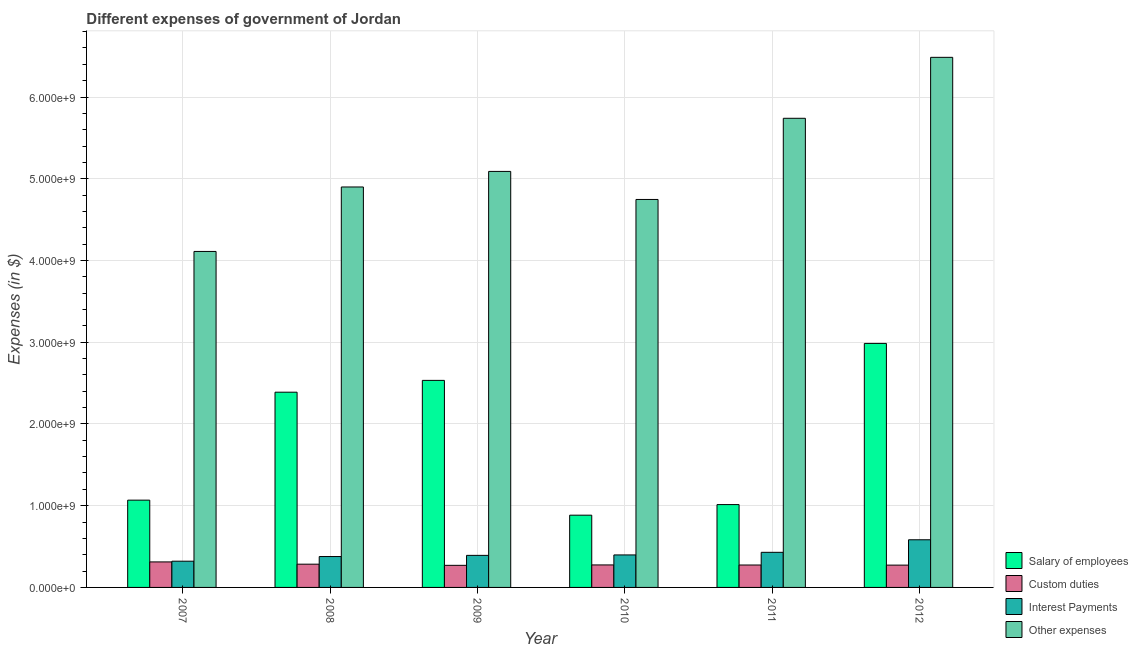How many groups of bars are there?
Ensure brevity in your answer.  6. Are the number of bars per tick equal to the number of legend labels?
Give a very brief answer. Yes. Are the number of bars on each tick of the X-axis equal?
Make the answer very short. Yes. How many bars are there on the 6th tick from the right?
Provide a succinct answer. 4. In how many cases, is the number of bars for a given year not equal to the number of legend labels?
Your answer should be compact. 0. What is the amount spent on custom duties in 2007?
Provide a succinct answer. 3.12e+08. Across all years, what is the maximum amount spent on interest payments?
Make the answer very short. 5.83e+08. Across all years, what is the minimum amount spent on custom duties?
Offer a terse response. 2.70e+08. What is the total amount spent on other expenses in the graph?
Provide a short and direct response. 3.11e+1. What is the difference between the amount spent on interest payments in 2011 and that in 2012?
Your response must be concise. -1.54e+08. What is the difference between the amount spent on other expenses in 2009 and the amount spent on custom duties in 2007?
Offer a very short reply. 9.79e+08. What is the average amount spent on other expenses per year?
Give a very brief answer. 5.18e+09. In the year 2012, what is the difference between the amount spent on interest payments and amount spent on salary of employees?
Offer a terse response. 0. What is the ratio of the amount spent on salary of employees in 2008 to that in 2012?
Your response must be concise. 0.8. Is the amount spent on custom duties in 2007 less than that in 2011?
Your answer should be very brief. No. What is the difference between the highest and the second highest amount spent on salary of employees?
Offer a terse response. 4.52e+08. What is the difference between the highest and the lowest amount spent on interest payments?
Your answer should be compact. 2.62e+08. Is the sum of the amount spent on interest payments in 2009 and 2012 greater than the maximum amount spent on custom duties across all years?
Offer a terse response. Yes. Is it the case that in every year, the sum of the amount spent on custom duties and amount spent on other expenses is greater than the sum of amount spent on interest payments and amount spent on salary of employees?
Ensure brevity in your answer.  No. What does the 1st bar from the left in 2010 represents?
Give a very brief answer. Salary of employees. What does the 1st bar from the right in 2010 represents?
Your response must be concise. Other expenses. Are all the bars in the graph horizontal?
Provide a short and direct response. No. How many years are there in the graph?
Make the answer very short. 6. What is the difference between two consecutive major ticks on the Y-axis?
Your answer should be compact. 1.00e+09. What is the title of the graph?
Offer a very short reply. Different expenses of government of Jordan. What is the label or title of the Y-axis?
Keep it short and to the point. Expenses (in $). What is the Expenses (in $) in Salary of employees in 2007?
Offer a very short reply. 1.07e+09. What is the Expenses (in $) of Custom duties in 2007?
Make the answer very short. 3.12e+08. What is the Expenses (in $) in Interest Payments in 2007?
Provide a succinct answer. 3.21e+08. What is the Expenses (in $) of Other expenses in 2007?
Your answer should be very brief. 4.11e+09. What is the Expenses (in $) of Salary of employees in 2008?
Your answer should be compact. 2.39e+09. What is the Expenses (in $) in Custom duties in 2008?
Keep it short and to the point. 2.84e+08. What is the Expenses (in $) of Interest Payments in 2008?
Make the answer very short. 3.78e+08. What is the Expenses (in $) in Other expenses in 2008?
Give a very brief answer. 4.90e+09. What is the Expenses (in $) in Salary of employees in 2009?
Your response must be concise. 2.53e+09. What is the Expenses (in $) of Custom duties in 2009?
Make the answer very short. 2.70e+08. What is the Expenses (in $) in Interest Payments in 2009?
Your answer should be compact. 3.92e+08. What is the Expenses (in $) of Other expenses in 2009?
Keep it short and to the point. 5.09e+09. What is the Expenses (in $) of Salary of employees in 2010?
Your answer should be compact. 8.84e+08. What is the Expenses (in $) in Custom duties in 2010?
Keep it short and to the point. 2.75e+08. What is the Expenses (in $) of Interest Payments in 2010?
Make the answer very short. 3.98e+08. What is the Expenses (in $) of Other expenses in 2010?
Make the answer very short. 4.75e+09. What is the Expenses (in $) of Salary of employees in 2011?
Make the answer very short. 1.01e+09. What is the Expenses (in $) of Custom duties in 2011?
Your response must be concise. 2.74e+08. What is the Expenses (in $) in Interest Payments in 2011?
Keep it short and to the point. 4.30e+08. What is the Expenses (in $) in Other expenses in 2011?
Provide a short and direct response. 5.74e+09. What is the Expenses (in $) in Salary of employees in 2012?
Provide a succinct answer. 2.99e+09. What is the Expenses (in $) of Custom duties in 2012?
Your answer should be compact. 2.73e+08. What is the Expenses (in $) in Interest Payments in 2012?
Your response must be concise. 5.83e+08. What is the Expenses (in $) of Other expenses in 2012?
Provide a succinct answer. 6.49e+09. Across all years, what is the maximum Expenses (in $) in Salary of employees?
Your answer should be compact. 2.99e+09. Across all years, what is the maximum Expenses (in $) in Custom duties?
Provide a short and direct response. 3.12e+08. Across all years, what is the maximum Expenses (in $) in Interest Payments?
Your answer should be compact. 5.83e+08. Across all years, what is the maximum Expenses (in $) of Other expenses?
Ensure brevity in your answer.  6.49e+09. Across all years, what is the minimum Expenses (in $) of Salary of employees?
Your answer should be compact. 8.84e+08. Across all years, what is the minimum Expenses (in $) of Custom duties?
Offer a very short reply. 2.70e+08. Across all years, what is the minimum Expenses (in $) of Interest Payments?
Offer a very short reply. 3.21e+08. Across all years, what is the minimum Expenses (in $) of Other expenses?
Provide a short and direct response. 4.11e+09. What is the total Expenses (in $) in Salary of employees in the graph?
Provide a short and direct response. 1.09e+1. What is the total Expenses (in $) of Custom duties in the graph?
Provide a short and direct response. 1.69e+09. What is the total Expenses (in $) of Interest Payments in the graph?
Provide a succinct answer. 2.50e+09. What is the total Expenses (in $) in Other expenses in the graph?
Your answer should be compact. 3.11e+1. What is the difference between the Expenses (in $) of Salary of employees in 2007 and that in 2008?
Provide a short and direct response. -1.32e+09. What is the difference between the Expenses (in $) in Custom duties in 2007 and that in 2008?
Offer a terse response. 2.77e+07. What is the difference between the Expenses (in $) of Interest Payments in 2007 and that in 2008?
Give a very brief answer. -5.69e+07. What is the difference between the Expenses (in $) in Other expenses in 2007 and that in 2008?
Offer a terse response. -7.89e+08. What is the difference between the Expenses (in $) of Salary of employees in 2007 and that in 2009?
Your answer should be compact. -1.47e+09. What is the difference between the Expenses (in $) of Custom duties in 2007 and that in 2009?
Make the answer very short. 4.18e+07. What is the difference between the Expenses (in $) of Interest Payments in 2007 and that in 2009?
Your answer should be compact. -7.13e+07. What is the difference between the Expenses (in $) of Other expenses in 2007 and that in 2009?
Make the answer very short. -9.79e+08. What is the difference between the Expenses (in $) of Salary of employees in 2007 and that in 2010?
Your response must be concise. 1.84e+08. What is the difference between the Expenses (in $) in Custom duties in 2007 and that in 2010?
Your answer should be very brief. 3.69e+07. What is the difference between the Expenses (in $) of Interest Payments in 2007 and that in 2010?
Your response must be concise. -7.66e+07. What is the difference between the Expenses (in $) of Other expenses in 2007 and that in 2010?
Your answer should be compact. -6.36e+08. What is the difference between the Expenses (in $) in Salary of employees in 2007 and that in 2011?
Provide a succinct answer. 5.42e+07. What is the difference between the Expenses (in $) of Custom duties in 2007 and that in 2011?
Your response must be concise. 3.79e+07. What is the difference between the Expenses (in $) in Interest Payments in 2007 and that in 2011?
Provide a short and direct response. -1.09e+08. What is the difference between the Expenses (in $) of Other expenses in 2007 and that in 2011?
Your answer should be very brief. -1.63e+09. What is the difference between the Expenses (in $) in Salary of employees in 2007 and that in 2012?
Offer a terse response. -1.92e+09. What is the difference between the Expenses (in $) in Custom duties in 2007 and that in 2012?
Your response must be concise. 3.91e+07. What is the difference between the Expenses (in $) in Interest Payments in 2007 and that in 2012?
Make the answer very short. -2.62e+08. What is the difference between the Expenses (in $) of Other expenses in 2007 and that in 2012?
Provide a succinct answer. -2.37e+09. What is the difference between the Expenses (in $) in Salary of employees in 2008 and that in 2009?
Give a very brief answer. -1.44e+08. What is the difference between the Expenses (in $) of Custom duties in 2008 and that in 2009?
Ensure brevity in your answer.  1.41e+07. What is the difference between the Expenses (in $) in Interest Payments in 2008 and that in 2009?
Provide a short and direct response. -1.44e+07. What is the difference between the Expenses (in $) in Other expenses in 2008 and that in 2009?
Your answer should be compact. -1.90e+08. What is the difference between the Expenses (in $) of Salary of employees in 2008 and that in 2010?
Keep it short and to the point. 1.50e+09. What is the difference between the Expenses (in $) of Custom duties in 2008 and that in 2010?
Make the answer very short. 9.20e+06. What is the difference between the Expenses (in $) in Interest Payments in 2008 and that in 2010?
Keep it short and to the point. -1.97e+07. What is the difference between the Expenses (in $) of Other expenses in 2008 and that in 2010?
Your answer should be compact. 1.53e+08. What is the difference between the Expenses (in $) of Salary of employees in 2008 and that in 2011?
Offer a very short reply. 1.38e+09. What is the difference between the Expenses (in $) of Custom duties in 2008 and that in 2011?
Provide a succinct answer. 1.02e+07. What is the difference between the Expenses (in $) of Interest Payments in 2008 and that in 2011?
Offer a very short reply. -5.17e+07. What is the difference between the Expenses (in $) in Other expenses in 2008 and that in 2011?
Your response must be concise. -8.40e+08. What is the difference between the Expenses (in $) of Salary of employees in 2008 and that in 2012?
Provide a succinct answer. -5.97e+08. What is the difference between the Expenses (in $) in Custom duties in 2008 and that in 2012?
Give a very brief answer. 1.14e+07. What is the difference between the Expenses (in $) of Interest Payments in 2008 and that in 2012?
Offer a very short reply. -2.05e+08. What is the difference between the Expenses (in $) of Other expenses in 2008 and that in 2012?
Provide a succinct answer. -1.59e+09. What is the difference between the Expenses (in $) of Salary of employees in 2009 and that in 2010?
Your answer should be very brief. 1.65e+09. What is the difference between the Expenses (in $) in Custom duties in 2009 and that in 2010?
Offer a terse response. -4.90e+06. What is the difference between the Expenses (in $) of Interest Payments in 2009 and that in 2010?
Give a very brief answer. -5.30e+06. What is the difference between the Expenses (in $) of Other expenses in 2009 and that in 2010?
Provide a succinct answer. 3.43e+08. What is the difference between the Expenses (in $) of Salary of employees in 2009 and that in 2011?
Offer a terse response. 1.52e+09. What is the difference between the Expenses (in $) in Custom duties in 2009 and that in 2011?
Keep it short and to the point. -3.90e+06. What is the difference between the Expenses (in $) in Interest Payments in 2009 and that in 2011?
Your response must be concise. -3.73e+07. What is the difference between the Expenses (in $) in Other expenses in 2009 and that in 2011?
Keep it short and to the point. -6.50e+08. What is the difference between the Expenses (in $) of Salary of employees in 2009 and that in 2012?
Your answer should be very brief. -4.52e+08. What is the difference between the Expenses (in $) in Custom duties in 2009 and that in 2012?
Your answer should be very brief. -2.70e+06. What is the difference between the Expenses (in $) of Interest Payments in 2009 and that in 2012?
Ensure brevity in your answer.  -1.91e+08. What is the difference between the Expenses (in $) of Other expenses in 2009 and that in 2012?
Offer a terse response. -1.40e+09. What is the difference between the Expenses (in $) of Salary of employees in 2010 and that in 2011?
Provide a succinct answer. -1.30e+08. What is the difference between the Expenses (in $) of Custom duties in 2010 and that in 2011?
Provide a short and direct response. 1.00e+06. What is the difference between the Expenses (in $) in Interest Payments in 2010 and that in 2011?
Make the answer very short. -3.20e+07. What is the difference between the Expenses (in $) in Other expenses in 2010 and that in 2011?
Provide a succinct answer. -9.93e+08. What is the difference between the Expenses (in $) in Salary of employees in 2010 and that in 2012?
Provide a short and direct response. -2.10e+09. What is the difference between the Expenses (in $) in Custom duties in 2010 and that in 2012?
Your answer should be compact. 2.20e+06. What is the difference between the Expenses (in $) of Interest Payments in 2010 and that in 2012?
Provide a succinct answer. -1.86e+08. What is the difference between the Expenses (in $) in Other expenses in 2010 and that in 2012?
Make the answer very short. -1.74e+09. What is the difference between the Expenses (in $) of Salary of employees in 2011 and that in 2012?
Offer a terse response. -1.97e+09. What is the difference between the Expenses (in $) of Custom duties in 2011 and that in 2012?
Provide a short and direct response. 1.20e+06. What is the difference between the Expenses (in $) in Interest Payments in 2011 and that in 2012?
Offer a terse response. -1.54e+08. What is the difference between the Expenses (in $) in Other expenses in 2011 and that in 2012?
Provide a short and direct response. -7.46e+08. What is the difference between the Expenses (in $) of Salary of employees in 2007 and the Expenses (in $) of Custom duties in 2008?
Provide a succinct answer. 7.83e+08. What is the difference between the Expenses (in $) in Salary of employees in 2007 and the Expenses (in $) in Interest Payments in 2008?
Provide a succinct answer. 6.90e+08. What is the difference between the Expenses (in $) in Salary of employees in 2007 and the Expenses (in $) in Other expenses in 2008?
Provide a short and direct response. -3.83e+09. What is the difference between the Expenses (in $) in Custom duties in 2007 and the Expenses (in $) in Interest Payments in 2008?
Provide a succinct answer. -6.57e+07. What is the difference between the Expenses (in $) of Custom duties in 2007 and the Expenses (in $) of Other expenses in 2008?
Offer a terse response. -4.59e+09. What is the difference between the Expenses (in $) in Interest Payments in 2007 and the Expenses (in $) in Other expenses in 2008?
Provide a short and direct response. -4.58e+09. What is the difference between the Expenses (in $) of Salary of employees in 2007 and the Expenses (in $) of Custom duties in 2009?
Provide a succinct answer. 7.97e+08. What is the difference between the Expenses (in $) of Salary of employees in 2007 and the Expenses (in $) of Interest Payments in 2009?
Make the answer very short. 6.76e+08. What is the difference between the Expenses (in $) of Salary of employees in 2007 and the Expenses (in $) of Other expenses in 2009?
Give a very brief answer. -4.02e+09. What is the difference between the Expenses (in $) of Custom duties in 2007 and the Expenses (in $) of Interest Payments in 2009?
Keep it short and to the point. -8.01e+07. What is the difference between the Expenses (in $) in Custom duties in 2007 and the Expenses (in $) in Other expenses in 2009?
Offer a very short reply. -4.78e+09. What is the difference between the Expenses (in $) in Interest Payments in 2007 and the Expenses (in $) in Other expenses in 2009?
Offer a terse response. -4.77e+09. What is the difference between the Expenses (in $) in Salary of employees in 2007 and the Expenses (in $) in Custom duties in 2010?
Your response must be concise. 7.92e+08. What is the difference between the Expenses (in $) of Salary of employees in 2007 and the Expenses (in $) of Interest Payments in 2010?
Ensure brevity in your answer.  6.70e+08. What is the difference between the Expenses (in $) in Salary of employees in 2007 and the Expenses (in $) in Other expenses in 2010?
Your response must be concise. -3.68e+09. What is the difference between the Expenses (in $) in Custom duties in 2007 and the Expenses (in $) in Interest Payments in 2010?
Ensure brevity in your answer.  -8.54e+07. What is the difference between the Expenses (in $) of Custom duties in 2007 and the Expenses (in $) of Other expenses in 2010?
Your answer should be very brief. -4.43e+09. What is the difference between the Expenses (in $) of Interest Payments in 2007 and the Expenses (in $) of Other expenses in 2010?
Offer a very short reply. -4.43e+09. What is the difference between the Expenses (in $) in Salary of employees in 2007 and the Expenses (in $) in Custom duties in 2011?
Offer a terse response. 7.94e+08. What is the difference between the Expenses (in $) in Salary of employees in 2007 and the Expenses (in $) in Interest Payments in 2011?
Give a very brief answer. 6.38e+08. What is the difference between the Expenses (in $) of Salary of employees in 2007 and the Expenses (in $) of Other expenses in 2011?
Ensure brevity in your answer.  -4.67e+09. What is the difference between the Expenses (in $) in Custom duties in 2007 and the Expenses (in $) in Interest Payments in 2011?
Offer a terse response. -1.17e+08. What is the difference between the Expenses (in $) of Custom duties in 2007 and the Expenses (in $) of Other expenses in 2011?
Provide a short and direct response. -5.43e+09. What is the difference between the Expenses (in $) of Interest Payments in 2007 and the Expenses (in $) of Other expenses in 2011?
Your answer should be compact. -5.42e+09. What is the difference between the Expenses (in $) in Salary of employees in 2007 and the Expenses (in $) in Custom duties in 2012?
Provide a succinct answer. 7.95e+08. What is the difference between the Expenses (in $) in Salary of employees in 2007 and the Expenses (in $) in Interest Payments in 2012?
Keep it short and to the point. 4.85e+08. What is the difference between the Expenses (in $) in Salary of employees in 2007 and the Expenses (in $) in Other expenses in 2012?
Your answer should be very brief. -5.42e+09. What is the difference between the Expenses (in $) of Custom duties in 2007 and the Expenses (in $) of Interest Payments in 2012?
Give a very brief answer. -2.71e+08. What is the difference between the Expenses (in $) in Custom duties in 2007 and the Expenses (in $) in Other expenses in 2012?
Offer a very short reply. -6.17e+09. What is the difference between the Expenses (in $) in Interest Payments in 2007 and the Expenses (in $) in Other expenses in 2012?
Ensure brevity in your answer.  -6.16e+09. What is the difference between the Expenses (in $) of Salary of employees in 2008 and the Expenses (in $) of Custom duties in 2009?
Your answer should be very brief. 2.12e+09. What is the difference between the Expenses (in $) in Salary of employees in 2008 and the Expenses (in $) in Interest Payments in 2009?
Offer a terse response. 2.00e+09. What is the difference between the Expenses (in $) of Salary of employees in 2008 and the Expenses (in $) of Other expenses in 2009?
Your response must be concise. -2.70e+09. What is the difference between the Expenses (in $) in Custom duties in 2008 and the Expenses (in $) in Interest Payments in 2009?
Provide a short and direct response. -1.08e+08. What is the difference between the Expenses (in $) of Custom duties in 2008 and the Expenses (in $) of Other expenses in 2009?
Your response must be concise. -4.81e+09. What is the difference between the Expenses (in $) of Interest Payments in 2008 and the Expenses (in $) of Other expenses in 2009?
Your answer should be very brief. -4.71e+09. What is the difference between the Expenses (in $) in Salary of employees in 2008 and the Expenses (in $) in Custom duties in 2010?
Your answer should be compact. 2.11e+09. What is the difference between the Expenses (in $) of Salary of employees in 2008 and the Expenses (in $) of Interest Payments in 2010?
Offer a terse response. 1.99e+09. What is the difference between the Expenses (in $) in Salary of employees in 2008 and the Expenses (in $) in Other expenses in 2010?
Keep it short and to the point. -2.36e+09. What is the difference between the Expenses (in $) in Custom duties in 2008 and the Expenses (in $) in Interest Payments in 2010?
Give a very brief answer. -1.13e+08. What is the difference between the Expenses (in $) in Custom duties in 2008 and the Expenses (in $) in Other expenses in 2010?
Make the answer very short. -4.46e+09. What is the difference between the Expenses (in $) in Interest Payments in 2008 and the Expenses (in $) in Other expenses in 2010?
Provide a succinct answer. -4.37e+09. What is the difference between the Expenses (in $) of Salary of employees in 2008 and the Expenses (in $) of Custom duties in 2011?
Your answer should be very brief. 2.11e+09. What is the difference between the Expenses (in $) in Salary of employees in 2008 and the Expenses (in $) in Interest Payments in 2011?
Give a very brief answer. 1.96e+09. What is the difference between the Expenses (in $) in Salary of employees in 2008 and the Expenses (in $) in Other expenses in 2011?
Offer a terse response. -3.35e+09. What is the difference between the Expenses (in $) of Custom duties in 2008 and the Expenses (in $) of Interest Payments in 2011?
Offer a terse response. -1.45e+08. What is the difference between the Expenses (in $) of Custom duties in 2008 and the Expenses (in $) of Other expenses in 2011?
Your response must be concise. -5.46e+09. What is the difference between the Expenses (in $) in Interest Payments in 2008 and the Expenses (in $) in Other expenses in 2011?
Provide a short and direct response. -5.36e+09. What is the difference between the Expenses (in $) of Salary of employees in 2008 and the Expenses (in $) of Custom duties in 2012?
Keep it short and to the point. 2.12e+09. What is the difference between the Expenses (in $) in Salary of employees in 2008 and the Expenses (in $) in Interest Payments in 2012?
Keep it short and to the point. 1.81e+09. What is the difference between the Expenses (in $) in Salary of employees in 2008 and the Expenses (in $) in Other expenses in 2012?
Offer a very short reply. -4.10e+09. What is the difference between the Expenses (in $) in Custom duties in 2008 and the Expenses (in $) in Interest Payments in 2012?
Provide a short and direct response. -2.99e+08. What is the difference between the Expenses (in $) of Custom duties in 2008 and the Expenses (in $) of Other expenses in 2012?
Your answer should be compact. -6.20e+09. What is the difference between the Expenses (in $) of Interest Payments in 2008 and the Expenses (in $) of Other expenses in 2012?
Offer a terse response. -6.11e+09. What is the difference between the Expenses (in $) in Salary of employees in 2009 and the Expenses (in $) in Custom duties in 2010?
Provide a succinct answer. 2.26e+09. What is the difference between the Expenses (in $) of Salary of employees in 2009 and the Expenses (in $) of Interest Payments in 2010?
Offer a very short reply. 2.14e+09. What is the difference between the Expenses (in $) of Salary of employees in 2009 and the Expenses (in $) of Other expenses in 2010?
Give a very brief answer. -2.21e+09. What is the difference between the Expenses (in $) in Custom duties in 2009 and the Expenses (in $) in Interest Payments in 2010?
Provide a short and direct response. -1.27e+08. What is the difference between the Expenses (in $) of Custom duties in 2009 and the Expenses (in $) of Other expenses in 2010?
Your response must be concise. -4.48e+09. What is the difference between the Expenses (in $) in Interest Payments in 2009 and the Expenses (in $) in Other expenses in 2010?
Provide a short and direct response. -4.35e+09. What is the difference between the Expenses (in $) in Salary of employees in 2009 and the Expenses (in $) in Custom duties in 2011?
Give a very brief answer. 2.26e+09. What is the difference between the Expenses (in $) in Salary of employees in 2009 and the Expenses (in $) in Interest Payments in 2011?
Provide a succinct answer. 2.10e+09. What is the difference between the Expenses (in $) of Salary of employees in 2009 and the Expenses (in $) of Other expenses in 2011?
Your answer should be compact. -3.21e+09. What is the difference between the Expenses (in $) of Custom duties in 2009 and the Expenses (in $) of Interest Payments in 2011?
Your answer should be very brief. -1.59e+08. What is the difference between the Expenses (in $) in Custom duties in 2009 and the Expenses (in $) in Other expenses in 2011?
Give a very brief answer. -5.47e+09. What is the difference between the Expenses (in $) of Interest Payments in 2009 and the Expenses (in $) of Other expenses in 2011?
Provide a short and direct response. -5.35e+09. What is the difference between the Expenses (in $) of Salary of employees in 2009 and the Expenses (in $) of Custom duties in 2012?
Give a very brief answer. 2.26e+09. What is the difference between the Expenses (in $) of Salary of employees in 2009 and the Expenses (in $) of Interest Payments in 2012?
Keep it short and to the point. 1.95e+09. What is the difference between the Expenses (in $) of Salary of employees in 2009 and the Expenses (in $) of Other expenses in 2012?
Provide a short and direct response. -3.95e+09. What is the difference between the Expenses (in $) in Custom duties in 2009 and the Expenses (in $) in Interest Payments in 2012?
Ensure brevity in your answer.  -3.13e+08. What is the difference between the Expenses (in $) of Custom duties in 2009 and the Expenses (in $) of Other expenses in 2012?
Ensure brevity in your answer.  -6.22e+09. What is the difference between the Expenses (in $) in Interest Payments in 2009 and the Expenses (in $) in Other expenses in 2012?
Ensure brevity in your answer.  -6.09e+09. What is the difference between the Expenses (in $) of Salary of employees in 2010 and the Expenses (in $) of Custom duties in 2011?
Make the answer very short. 6.10e+08. What is the difference between the Expenses (in $) of Salary of employees in 2010 and the Expenses (in $) of Interest Payments in 2011?
Keep it short and to the point. 4.54e+08. What is the difference between the Expenses (in $) of Salary of employees in 2010 and the Expenses (in $) of Other expenses in 2011?
Provide a succinct answer. -4.86e+09. What is the difference between the Expenses (in $) of Custom duties in 2010 and the Expenses (in $) of Interest Payments in 2011?
Offer a very short reply. -1.54e+08. What is the difference between the Expenses (in $) of Custom duties in 2010 and the Expenses (in $) of Other expenses in 2011?
Give a very brief answer. -5.46e+09. What is the difference between the Expenses (in $) in Interest Payments in 2010 and the Expenses (in $) in Other expenses in 2011?
Provide a succinct answer. -5.34e+09. What is the difference between the Expenses (in $) in Salary of employees in 2010 and the Expenses (in $) in Custom duties in 2012?
Offer a terse response. 6.11e+08. What is the difference between the Expenses (in $) in Salary of employees in 2010 and the Expenses (in $) in Interest Payments in 2012?
Give a very brief answer. 3.01e+08. What is the difference between the Expenses (in $) in Salary of employees in 2010 and the Expenses (in $) in Other expenses in 2012?
Make the answer very short. -5.60e+09. What is the difference between the Expenses (in $) in Custom duties in 2010 and the Expenses (in $) in Interest Payments in 2012?
Keep it short and to the point. -3.08e+08. What is the difference between the Expenses (in $) of Custom duties in 2010 and the Expenses (in $) of Other expenses in 2012?
Your response must be concise. -6.21e+09. What is the difference between the Expenses (in $) in Interest Payments in 2010 and the Expenses (in $) in Other expenses in 2012?
Provide a succinct answer. -6.09e+09. What is the difference between the Expenses (in $) of Salary of employees in 2011 and the Expenses (in $) of Custom duties in 2012?
Your answer should be compact. 7.40e+08. What is the difference between the Expenses (in $) in Salary of employees in 2011 and the Expenses (in $) in Interest Payments in 2012?
Make the answer very short. 4.30e+08. What is the difference between the Expenses (in $) in Salary of employees in 2011 and the Expenses (in $) in Other expenses in 2012?
Keep it short and to the point. -5.47e+09. What is the difference between the Expenses (in $) of Custom duties in 2011 and the Expenses (in $) of Interest Payments in 2012?
Offer a very short reply. -3.09e+08. What is the difference between the Expenses (in $) in Custom duties in 2011 and the Expenses (in $) in Other expenses in 2012?
Give a very brief answer. -6.21e+09. What is the difference between the Expenses (in $) in Interest Payments in 2011 and the Expenses (in $) in Other expenses in 2012?
Offer a terse response. -6.06e+09. What is the average Expenses (in $) in Salary of employees per year?
Provide a succinct answer. 1.81e+09. What is the average Expenses (in $) in Custom duties per year?
Offer a very short reply. 2.82e+08. What is the average Expenses (in $) in Interest Payments per year?
Offer a very short reply. 4.17e+08. What is the average Expenses (in $) in Other expenses per year?
Give a very brief answer. 5.18e+09. In the year 2007, what is the difference between the Expenses (in $) of Salary of employees and Expenses (in $) of Custom duties?
Provide a succinct answer. 7.56e+08. In the year 2007, what is the difference between the Expenses (in $) of Salary of employees and Expenses (in $) of Interest Payments?
Offer a very short reply. 7.47e+08. In the year 2007, what is the difference between the Expenses (in $) in Salary of employees and Expenses (in $) in Other expenses?
Keep it short and to the point. -3.04e+09. In the year 2007, what is the difference between the Expenses (in $) in Custom duties and Expenses (in $) in Interest Payments?
Your answer should be compact. -8.80e+06. In the year 2007, what is the difference between the Expenses (in $) in Custom duties and Expenses (in $) in Other expenses?
Offer a very short reply. -3.80e+09. In the year 2007, what is the difference between the Expenses (in $) in Interest Payments and Expenses (in $) in Other expenses?
Ensure brevity in your answer.  -3.79e+09. In the year 2008, what is the difference between the Expenses (in $) in Salary of employees and Expenses (in $) in Custom duties?
Keep it short and to the point. 2.10e+09. In the year 2008, what is the difference between the Expenses (in $) in Salary of employees and Expenses (in $) in Interest Payments?
Make the answer very short. 2.01e+09. In the year 2008, what is the difference between the Expenses (in $) in Salary of employees and Expenses (in $) in Other expenses?
Give a very brief answer. -2.51e+09. In the year 2008, what is the difference between the Expenses (in $) in Custom duties and Expenses (in $) in Interest Payments?
Offer a terse response. -9.34e+07. In the year 2008, what is the difference between the Expenses (in $) in Custom duties and Expenses (in $) in Other expenses?
Provide a succinct answer. -4.61e+09. In the year 2008, what is the difference between the Expenses (in $) of Interest Payments and Expenses (in $) of Other expenses?
Make the answer very short. -4.52e+09. In the year 2009, what is the difference between the Expenses (in $) of Salary of employees and Expenses (in $) of Custom duties?
Ensure brevity in your answer.  2.26e+09. In the year 2009, what is the difference between the Expenses (in $) of Salary of employees and Expenses (in $) of Interest Payments?
Your answer should be very brief. 2.14e+09. In the year 2009, what is the difference between the Expenses (in $) in Salary of employees and Expenses (in $) in Other expenses?
Your answer should be compact. -2.56e+09. In the year 2009, what is the difference between the Expenses (in $) of Custom duties and Expenses (in $) of Interest Payments?
Give a very brief answer. -1.22e+08. In the year 2009, what is the difference between the Expenses (in $) of Custom duties and Expenses (in $) of Other expenses?
Your response must be concise. -4.82e+09. In the year 2009, what is the difference between the Expenses (in $) in Interest Payments and Expenses (in $) in Other expenses?
Ensure brevity in your answer.  -4.70e+09. In the year 2010, what is the difference between the Expenses (in $) in Salary of employees and Expenses (in $) in Custom duties?
Give a very brief answer. 6.09e+08. In the year 2010, what is the difference between the Expenses (in $) in Salary of employees and Expenses (in $) in Interest Payments?
Provide a succinct answer. 4.86e+08. In the year 2010, what is the difference between the Expenses (in $) of Salary of employees and Expenses (in $) of Other expenses?
Offer a terse response. -3.86e+09. In the year 2010, what is the difference between the Expenses (in $) of Custom duties and Expenses (in $) of Interest Payments?
Your answer should be very brief. -1.22e+08. In the year 2010, what is the difference between the Expenses (in $) of Custom duties and Expenses (in $) of Other expenses?
Make the answer very short. -4.47e+09. In the year 2010, what is the difference between the Expenses (in $) in Interest Payments and Expenses (in $) in Other expenses?
Your answer should be very brief. -4.35e+09. In the year 2011, what is the difference between the Expenses (in $) of Salary of employees and Expenses (in $) of Custom duties?
Ensure brevity in your answer.  7.39e+08. In the year 2011, what is the difference between the Expenses (in $) in Salary of employees and Expenses (in $) in Interest Payments?
Make the answer very short. 5.84e+08. In the year 2011, what is the difference between the Expenses (in $) in Salary of employees and Expenses (in $) in Other expenses?
Your response must be concise. -4.73e+09. In the year 2011, what is the difference between the Expenses (in $) of Custom duties and Expenses (in $) of Interest Payments?
Keep it short and to the point. -1.55e+08. In the year 2011, what is the difference between the Expenses (in $) in Custom duties and Expenses (in $) in Other expenses?
Give a very brief answer. -5.47e+09. In the year 2011, what is the difference between the Expenses (in $) of Interest Payments and Expenses (in $) of Other expenses?
Provide a succinct answer. -5.31e+09. In the year 2012, what is the difference between the Expenses (in $) of Salary of employees and Expenses (in $) of Custom duties?
Give a very brief answer. 2.71e+09. In the year 2012, what is the difference between the Expenses (in $) in Salary of employees and Expenses (in $) in Interest Payments?
Provide a succinct answer. 2.40e+09. In the year 2012, what is the difference between the Expenses (in $) in Salary of employees and Expenses (in $) in Other expenses?
Provide a succinct answer. -3.50e+09. In the year 2012, what is the difference between the Expenses (in $) of Custom duties and Expenses (in $) of Interest Payments?
Make the answer very short. -3.10e+08. In the year 2012, what is the difference between the Expenses (in $) of Custom duties and Expenses (in $) of Other expenses?
Provide a short and direct response. -6.21e+09. In the year 2012, what is the difference between the Expenses (in $) of Interest Payments and Expenses (in $) of Other expenses?
Provide a succinct answer. -5.90e+09. What is the ratio of the Expenses (in $) of Salary of employees in 2007 to that in 2008?
Your answer should be very brief. 0.45. What is the ratio of the Expenses (in $) in Custom duties in 2007 to that in 2008?
Keep it short and to the point. 1.1. What is the ratio of the Expenses (in $) of Interest Payments in 2007 to that in 2008?
Offer a very short reply. 0.85. What is the ratio of the Expenses (in $) of Other expenses in 2007 to that in 2008?
Keep it short and to the point. 0.84. What is the ratio of the Expenses (in $) of Salary of employees in 2007 to that in 2009?
Provide a succinct answer. 0.42. What is the ratio of the Expenses (in $) in Custom duties in 2007 to that in 2009?
Keep it short and to the point. 1.15. What is the ratio of the Expenses (in $) in Interest Payments in 2007 to that in 2009?
Your response must be concise. 0.82. What is the ratio of the Expenses (in $) in Other expenses in 2007 to that in 2009?
Your answer should be very brief. 0.81. What is the ratio of the Expenses (in $) of Salary of employees in 2007 to that in 2010?
Your response must be concise. 1.21. What is the ratio of the Expenses (in $) in Custom duties in 2007 to that in 2010?
Offer a terse response. 1.13. What is the ratio of the Expenses (in $) of Interest Payments in 2007 to that in 2010?
Ensure brevity in your answer.  0.81. What is the ratio of the Expenses (in $) in Other expenses in 2007 to that in 2010?
Your answer should be compact. 0.87. What is the ratio of the Expenses (in $) of Salary of employees in 2007 to that in 2011?
Offer a very short reply. 1.05. What is the ratio of the Expenses (in $) of Custom duties in 2007 to that in 2011?
Make the answer very short. 1.14. What is the ratio of the Expenses (in $) of Interest Payments in 2007 to that in 2011?
Provide a succinct answer. 0.75. What is the ratio of the Expenses (in $) of Other expenses in 2007 to that in 2011?
Offer a very short reply. 0.72. What is the ratio of the Expenses (in $) of Salary of employees in 2007 to that in 2012?
Provide a succinct answer. 0.36. What is the ratio of the Expenses (in $) in Custom duties in 2007 to that in 2012?
Offer a very short reply. 1.14. What is the ratio of the Expenses (in $) in Interest Payments in 2007 to that in 2012?
Provide a succinct answer. 0.55. What is the ratio of the Expenses (in $) in Other expenses in 2007 to that in 2012?
Your answer should be compact. 0.63. What is the ratio of the Expenses (in $) of Salary of employees in 2008 to that in 2009?
Give a very brief answer. 0.94. What is the ratio of the Expenses (in $) of Custom duties in 2008 to that in 2009?
Provide a succinct answer. 1.05. What is the ratio of the Expenses (in $) of Interest Payments in 2008 to that in 2009?
Your answer should be compact. 0.96. What is the ratio of the Expenses (in $) in Other expenses in 2008 to that in 2009?
Your response must be concise. 0.96. What is the ratio of the Expenses (in $) in Salary of employees in 2008 to that in 2010?
Ensure brevity in your answer.  2.7. What is the ratio of the Expenses (in $) of Custom duties in 2008 to that in 2010?
Keep it short and to the point. 1.03. What is the ratio of the Expenses (in $) of Interest Payments in 2008 to that in 2010?
Keep it short and to the point. 0.95. What is the ratio of the Expenses (in $) of Other expenses in 2008 to that in 2010?
Give a very brief answer. 1.03. What is the ratio of the Expenses (in $) in Salary of employees in 2008 to that in 2011?
Keep it short and to the point. 2.36. What is the ratio of the Expenses (in $) in Custom duties in 2008 to that in 2011?
Keep it short and to the point. 1.04. What is the ratio of the Expenses (in $) in Interest Payments in 2008 to that in 2011?
Keep it short and to the point. 0.88. What is the ratio of the Expenses (in $) in Other expenses in 2008 to that in 2011?
Ensure brevity in your answer.  0.85. What is the ratio of the Expenses (in $) in Salary of employees in 2008 to that in 2012?
Give a very brief answer. 0.8. What is the ratio of the Expenses (in $) in Custom duties in 2008 to that in 2012?
Provide a short and direct response. 1.04. What is the ratio of the Expenses (in $) of Interest Payments in 2008 to that in 2012?
Your response must be concise. 0.65. What is the ratio of the Expenses (in $) in Other expenses in 2008 to that in 2012?
Make the answer very short. 0.76. What is the ratio of the Expenses (in $) in Salary of employees in 2009 to that in 2010?
Make the answer very short. 2.87. What is the ratio of the Expenses (in $) of Custom duties in 2009 to that in 2010?
Your answer should be compact. 0.98. What is the ratio of the Expenses (in $) of Interest Payments in 2009 to that in 2010?
Provide a succinct answer. 0.99. What is the ratio of the Expenses (in $) in Other expenses in 2009 to that in 2010?
Your answer should be very brief. 1.07. What is the ratio of the Expenses (in $) of Salary of employees in 2009 to that in 2011?
Make the answer very short. 2.5. What is the ratio of the Expenses (in $) in Custom duties in 2009 to that in 2011?
Your answer should be very brief. 0.99. What is the ratio of the Expenses (in $) in Interest Payments in 2009 to that in 2011?
Your answer should be very brief. 0.91. What is the ratio of the Expenses (in $) in Other expenses in 2009 to that in 2011?
Provide a short and direct response. 0.89. What is the ratio of the Expenses (in $) of Salary of employees in 2009 to that in 2012?
Keep it short and to the point. 0.85. What is the ratio of the Expenses (in $) in Interest Payments in 2009 to that in 2012?
Your answer should be very brief. 0.67. What is the ratio of the Expenses (in $) in Other expenses in 2009 to that in 2012?
Your answer should be very brief. 0.78. What is the ratio of the Expenses (in $) of Salary of employees in 2010 to that in 2011?
Keep it short and to the point. 0.87. What is the ratio of the Expenses (in $) of Interest Payments in 2010 to that in 2011?
Your response must be concise. 0.93. What is the ratio of the Expenses (in $) in Other expenses in 2010 to that in 2011?
Your answer should be very brief. 0.83. What is the ratio of the Expenses (in $) of Salary of employees in 2010 to that in 2012?
Keep it short and to the point. 0.3. What is the ratio of the Expenses (in $) of Interest Payments in 2010 to that in 2012?
Offer a very short reply. 0.68. What is the ratio of the Expenses (in $) in Other expenses in 2010 to that in 2012?
Provide a short and direct response. 0.73. What is the ratio of the Expenses (in $) of Salary of employees in 2011 to that in 2012?
Your response must be concise. 0.34. What is the ratio of the Expenses (in $) in Custom duties in 2011 to that in 2012?
Your answer should be compact. 1. What is the ratio of the Expenses (in $) of Interest Payments in 2011 to that in 2012?
Your answer should be very brief. 0.74. What is the ratio of the Expenses (in $) of Other expenses in 2011 to that in 2012?
Offer a very short reply. 0.89. What is the difference between the highest and the second highest Expenses (in $) in Salary of employees?
Your answer should be very brief. 4.52e+08. What is the difference between the highest and the second highest Expenses (in $) in Custom duties?
Keep it short and to the point. 2.77e+07. What is the difference between the highest and the second highest Expenses (in $) of Interest Payments?
Provide a short and direct response. 1.54e+08. What is the difference between the highest and the second highest Expenses (in $) of Other expenses?
Offer a very short reply. 7.46e+08. What is the difference between the highest and the lowest Expenses (in $) of Salary of employees?
Provide a short and direct response. 2.10e+09. What is the difference between the highest and the lowest Expenses (in $) of Custom duties?
Your answer should be compact. 4.18e+07. What is the difference between the highest and the lowest Expenses (in $) in Interest Payments?
Offer a terse response. 2.62e+08. What is the difference between the highest and the lowest Expenses (in $) of Other expenses?
Your answer should be very brief. 2.37e+09. 